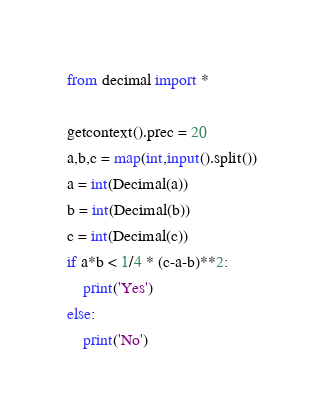Convert code to text. <code><loc_0><loc_0><loc_500><loc_500><_Python_>from decimal import *

getcontext().prec = 20
a,b,c = map(int,input().split())
a = int(Decimal(a))
b = int(Decimal(b))
c = int(Decimal(c))
if a*b < 1/4 * (c-a-b)**2:
    print('Yes')
else:
    print('No')
</code> 